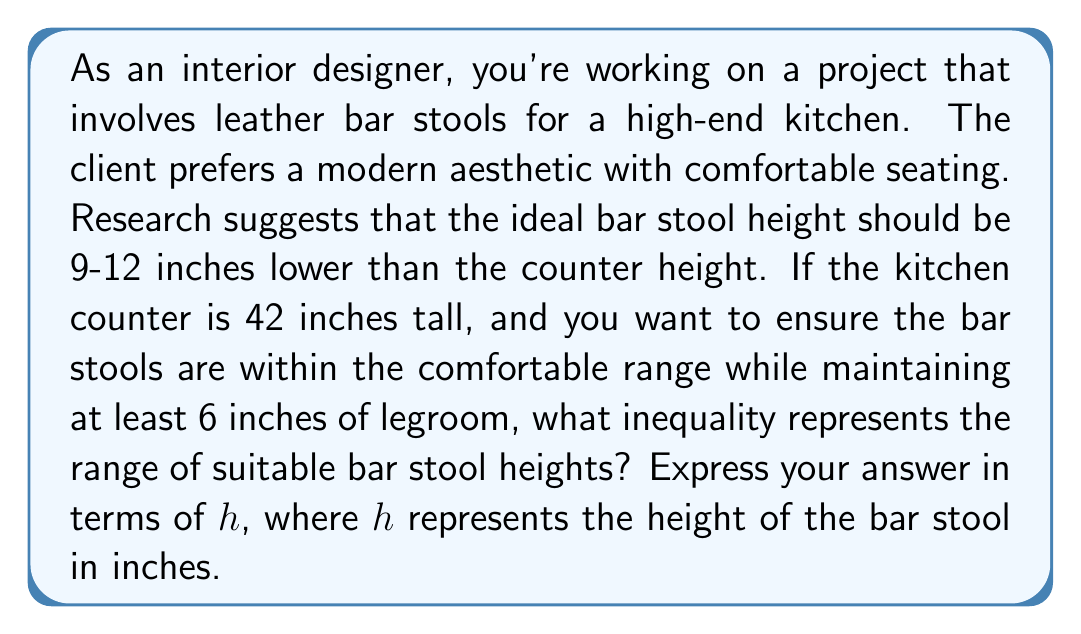Provide a solution to this math problem. To solve this problem, we need to consider both the upper and lower limits for the bar stool height:

1. Upper limit:
   - The bar stool should be at least 9 inches lower than the counter height.
   - Counter height: 42 inches
   - Maximum stool height: $42 - 9 = 33$ inches

2. Lower limit:
   - The bar stool should be no more than 12 inches lower than the counter height.
   - Minimum stool height based on counter: $42 - 12 = 30$ inches
   - However, we need to ensure at least 6 inches of legroom.
   - Minimum stool height considering legroom: $42 - 6 = 36$ inches
   - We take the larger of these two values: $\max(30, 36) = 36$ inches

3. Combining the limits:
   - The stool height $h$ should be greater than or equal to 30 inches (from step 2)
   - The stool height $h$ should be less than or equal to 33 inches (from step 1)

4. Expressing as an inequality:
   $$30 \leq h \leq 33$$

This inequality represents the range of suitable bar stool heights that meet both the comfort requirements and the aesthetic preferences for the modern kitchen design.
Answer: $$30 \leq h \leq 33$$ 